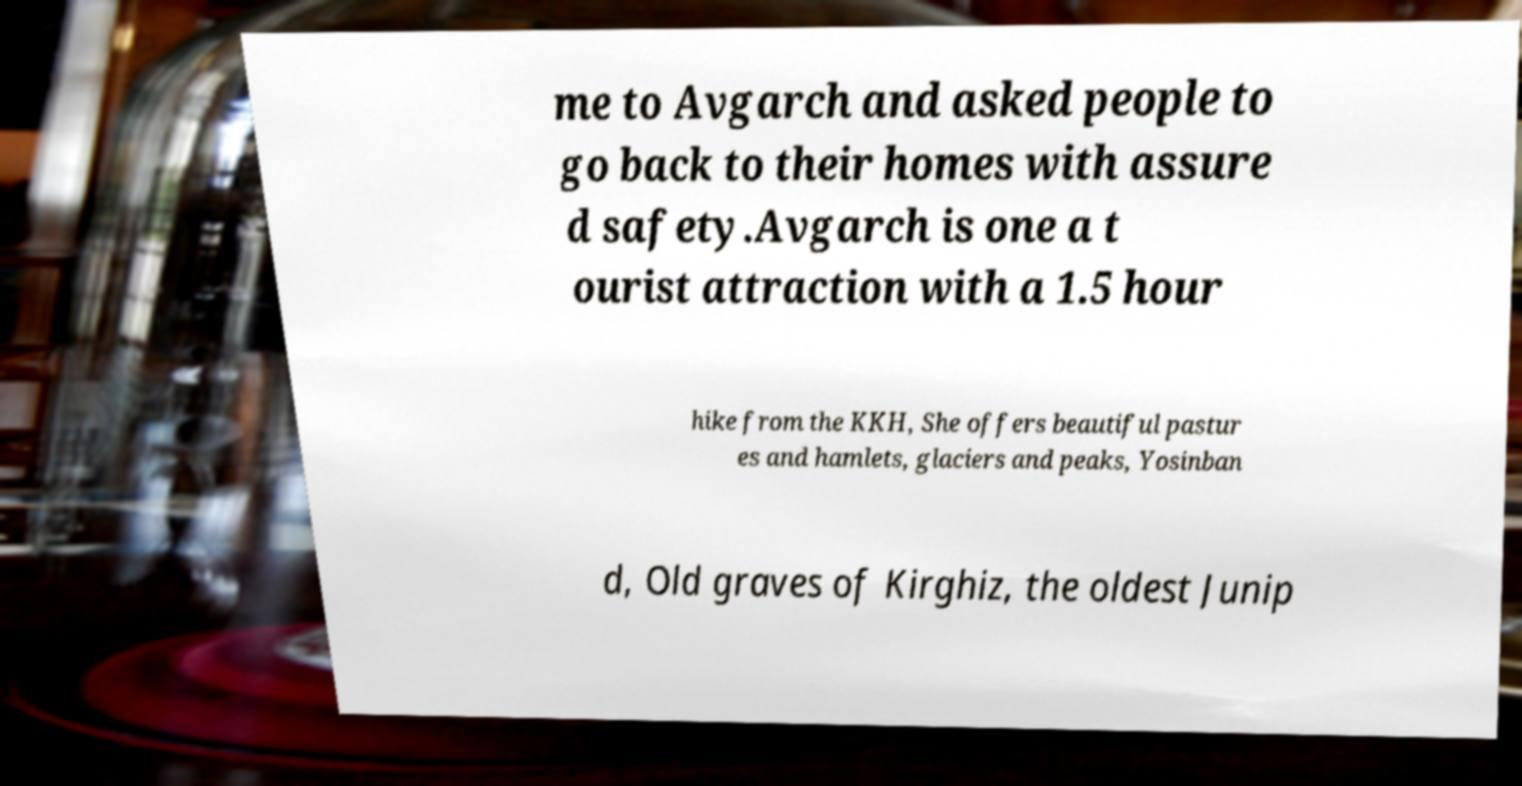I need the written content from this picture converted into text. Can you do that? me to Avgarch and asked people to go back to their homes with assure d safety.Avgarch is one a t ourist attraction with a 1.5 hour hike from the KKH, She offers beautiful pastur es and hamlets, glaciers and peaks, Yosinban d, Old graves of Kirghiz, the oldest Junip 